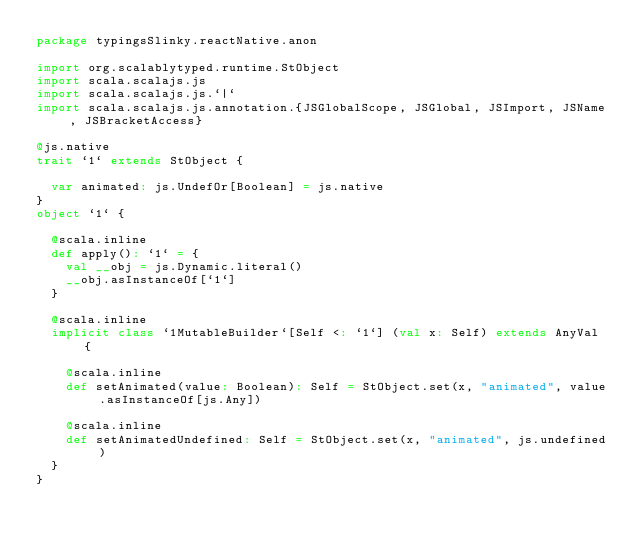<code> <loc_0><loc_0><loc_500><loc_500><_Scala_>package typingsSlinky.reactNative.anon

import org.scalablytyped.runtime.StObject
import scala.scalajs.js
import scala.scalajs.js.`|`
import scala.scalajs.js.annotation.{JSGlobalScope, JSGlobal, JSImport, JSName, JSBracketAccess}

@js.native
trait `1` extends StObject {
  
  var animated: js.UndefOr[Boolean] = js.native
}
object `1` {
  
  @scala.inline
  def apply(): `1` = {
    val __obj = js.Dynamic.literal()
    __obj.asInstanceOf[`1`]
  }
  
  @scala.inline
  implicit class `1MutableBuilder`[Self <: `1`] (val x: Self) extends AnyVal {
    
    @scala.inline
    def setAnimated(value: Boolean): Self = StObject.set(x, "animated", value.asInstanceOf[js.Any])
    
    @scala.inline
    def setAnimatedUndefined: Self = StObject.set(x, "animated", js.undefined)
  }
}
</code> 